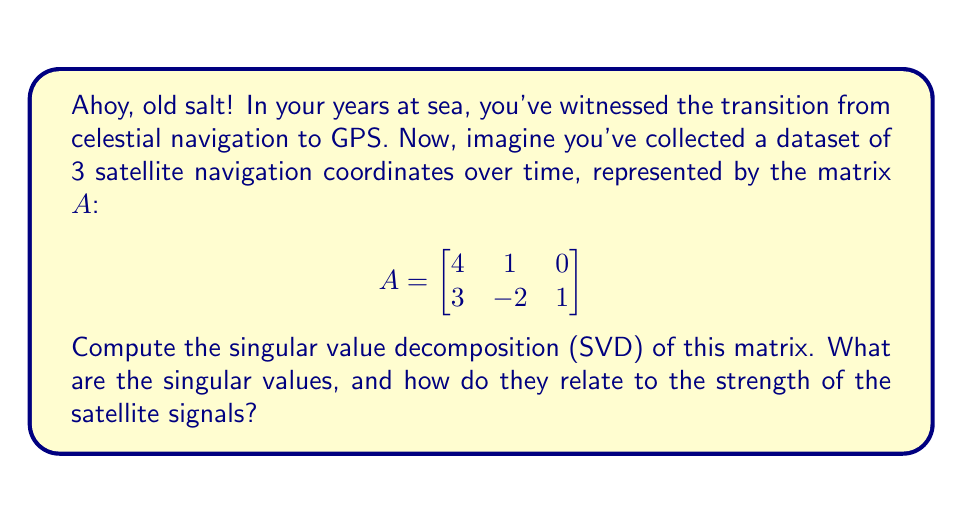Give your solution to this math problem. To find the singular value decomposition of matrix $A$, we follow these steps:

1) First, we calculate $A^TA$ and $AA^T$:

   $A^TA = \begin{bmatrix}
   4 & 3 \\
   1 & -2 \\
   0 & 1
   \end{bmatrix} \begin{bmatrix}
   4 & 1 & 0 \\
   3 & -2 & 1
   \end{bmatrix} = \begin{bmatrix}
   25 & -2 & 3 \\
   -2 & 5 & -2 \\
   3 & -2 & 1
   \end{bmatrix}$

   $AA^T = \begin{bmatrix}
   4 & 1 & 0 \\
   3 & -2 & 1
   \end{bmatrix} \begin{bmatrix}
   4 & 3 \\
   1 & -2 \\
   0 & 1
   \end{bmatrix} = \begin{bmatrix}
   17 & 10 \\
   10 & 14
   \end{bmatrix}$

2) We find the eigenvalues of $AA^T$ (which are the squares of the singular values):

   $det(AA^T - \lambda I) = \begin{vmatrix}
   17-\lambda & 10 \\
   10 & 14-\lambda
   \end{vmatrix} = (17-\lambda)(14-\lambda) - 100 = \lambda^2 - 31\lambda + 138 = 0$

   Solving this quadratic equation gives us:
   $\lambda_1 = 26$ and $\lambda_2 = 5$

3) The singular values are the square roots of these eigenvalues:

   $\sigma_1 = \sqrt{26} \approx 5.10$ and $\sigma_2 = \sqrt{5} \approx 2.24$

4) These singular values represent the strength or importance of each "signal" in our data. The larger singular value ($\sigma_1$) corresponds to the stronger, more dominant signal, while the smaller one ($\sigma_2$) represents a weaker, secondary signal.

5) In the context of satellite navigation, these could be interpreted as the relative strengths of different satellite signals or navigation factors influencing the recorded coordinates.
Answer: $\sigma_1 \approx 5.10, \sigma_2 \approx 2.24$; larger values indicate stronger signals. 